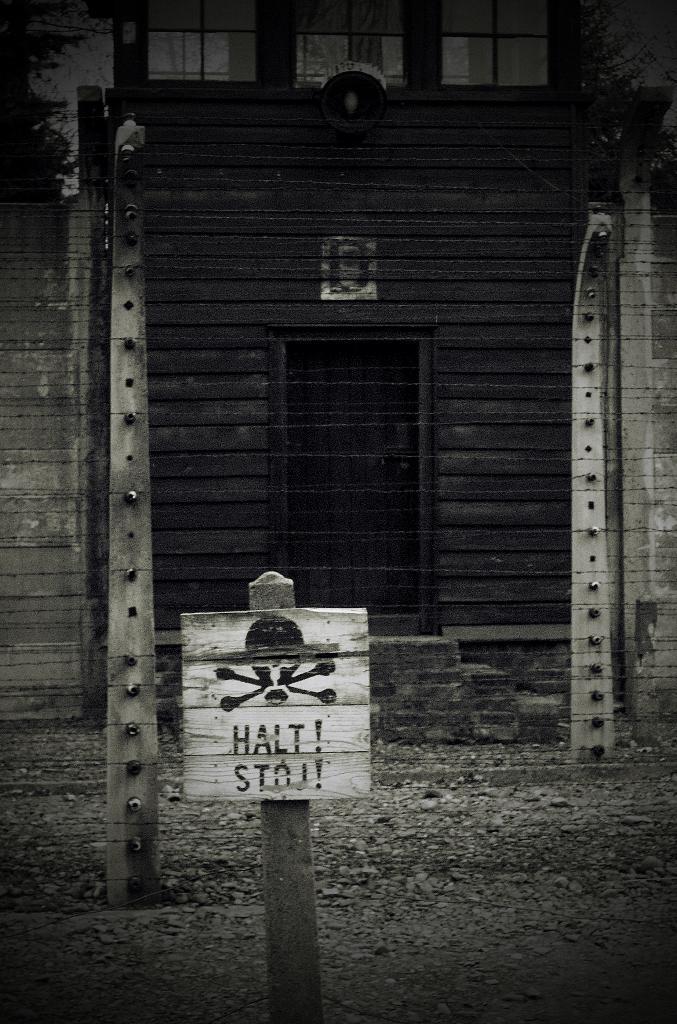Can you describe this image briefly? In the foreground of the image we can see a sign board placed on a pole. In the background ,we can see a fence ,building with windows ,door and a lamp on it. 